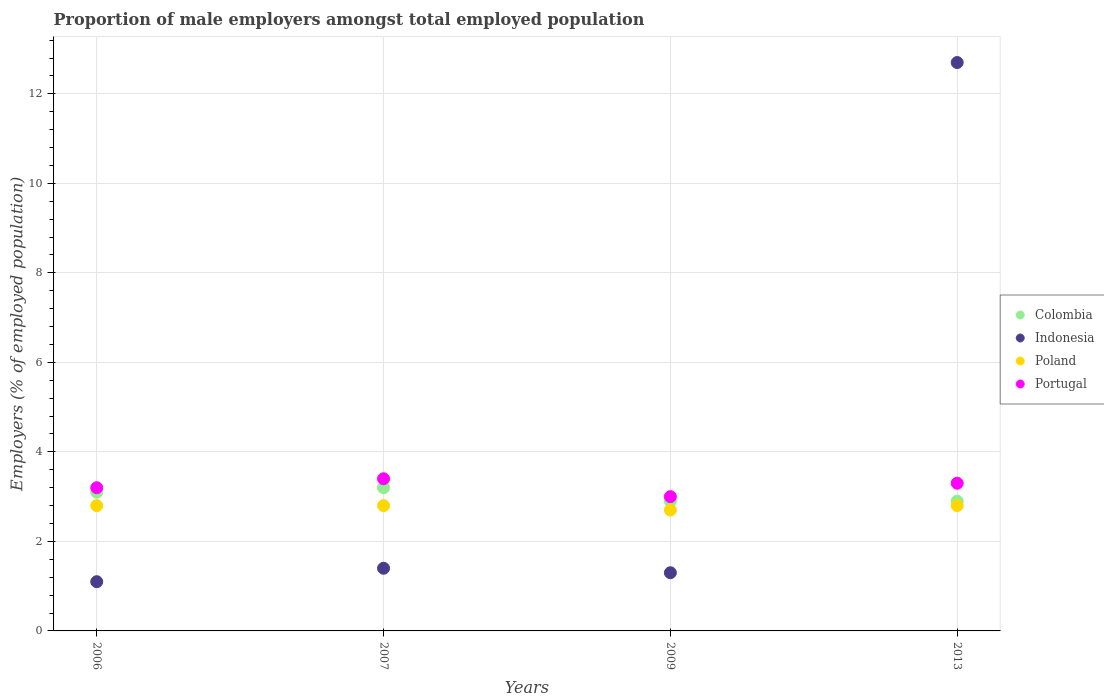What is the proportion of male employers in Indonesia in 2009?
Your response must be concise. 1.3. Across all years, what is the maximum proportion of male employers in Portugal?
Your answer should be very brief. 3.4. Across all years, what is the minimum proportion of male employers in Indonesia?
Make the answer very short. 1.1. What is the total proportion of male employers in Colombia in the graph?
Offer a very short reply. 12.1. What is the difference between the proportion of male employers in Portugal in 2013 and the proportion of male employers in Indonesia in 2007?
Your answer should be very brief. 1.9. What is the average proportion of male employers in Portugal per year?
Your answer should be compact. 3.23. In the year 2009, what is the difference between the proportion of male employers in Colombia and proportion of male employers in Portugal?
Provide a succinct answer. -0.1. In how many years, is the proportion of male employers in Indonesia greater than 12 %?
Provide a short and direct response. 1. Is the difference between the proportion of male employers in Colombia in 2006 and 2009 greater than the difference between the proportion of male employers in Portugal in 2006 and 2009?
Provide a short and direct response. No. What is the difference between the highest and the lowest proportion of male employers in Colombia?
Offer a very short reply. 0.3. In how many years, is the proportion of male employers in Colombia greater than the average proportion of male employers in Colombia taken over all years?
Give a very brief answer. 2. Is the sum of the proportion of male employers in Colombia in 2006 and 2013 greater than the maximum proportion of male employers in Poland across all years?
Offer a very short reply. Yes. Is it the case that in every year, the sum of the proportion of male employers in Portugal and proportion of male employers in Indonesia  is greater than the sum of proportion of male employers in Colombia and proportion of male employers in Poland?
Ensure brevity in your answer.  No. Does the proportion of male employers in Portugal monotonically increase over the years?
Offer a very short reply. No. Is the proportion of male employers in Indonesia strictly greater than the proportion of male employers in Poland over the years?
Your answer should be compact. No. Are the values on the major ticks of Y-axis written in scientific E-notation?
Give a very brief answer. No. Does the graph contain any zero values?
Give a very brief answer. No. What is the title of the graph?
Offer a very short reply. Proportion of male employers amongst total employed population. What is the label or title of the X-axis?
Offer a very short reply. Years. What is the label or title of the Y-axis?
Ensure brevity in your answer.  Employers (% of employed population). What is the Employers (% of employed population) in Colombia in 2006?
Your answer should be very brief. 3.1. What is the Employers (% of employed population) of Indonesia in 2006?
Keep it short and to the point. 1.1. What is the Employers (% of employed population) of Poland in 2006?
Provide a succinct answer. 2.8. What is the Employers (% of employed population) in Portugal in 2006?
Ensure brevity in your answer.  3.2. What is the Employers (% of employed population) of Colombia in 2007?
Give a very brief answer. 3.2. What is the Employers (% of employed population) of Indonesia in 2007?
Make the answer very short. 1.4. What is the Employers (% of employed population) in Poland in 2007?
Give a very brief answer. 2.8. What is the Employers (% of employed population) in Portugal in 2007?
Offer a very short reply. 3.4. What is the Employers (% of employed population) in Colombia in 2009?
Your answer should be compact. 2.9. What is the Employers (% of employed population) in Indonesia in 2009?
Ensure brevity in your answer.  1.3. What is the Employers (% of employed population) in Poland in 2009?
Provide a short and direct response. 2.7. What is the Employers (% of employed population) in Portugal in 2009?
Make the answer very short. 3. What is the Employers (% of employed population) of Colombia in 2013?
Offer a terse response. 2.9. What is the Employers (% of employed population) of Indonesia in 2013?
Your answer should be compact. 12.7. What is the Employers (% of employed population) in Poland in 2013?
Provide a succinct answer. 2.8. What is the Employers (% of employed population) in Portugal in 2013?
Your response must be concise. 3.3. Across all years, what is the maximum Employers (% of employed population) in Colombia?
Keep it short and to the point. 3.2. Across all years, what is the maximum Employers (% of employed population) of Indonesia?
Provide a short and direct response. 12.7. Across all years, what is the maximum Employers (% of employed population) of Poland?
Provide a succinct answer. 2.8. Across all years, what is the maximum Employers (% of employed population) of Portugal?
Your answer should be compact. 3.4. Across all years, what is the minimum Employers (% of employed population) of Colombia?
Provide a short and direct response. 2.9. Across all years, what is the minimum Employers (% of employed population) in Indonesia?
Your answer should be very brief. 1.1. Across all years, what is the minimum Employers (% of employed population) in Poland?
Offer a very short reply. 2.7. Across all years, what is the minimum Employers (% of employed population) of Portugal?
Offer a terse response. 3. What is the total Employers (% of employed population) in Colombia in the graph?
Give a very brief answer. 12.1. What is the difference between the Employers (% of employed population) of Colombia in 2006 and that in 2009?
Keep it short and to the point. 0.2. What is the difference between the Employers (% of employed population) in Indonesia in 2006 and that in 2009?
Your answer should be very brief. -0.2. What is the difference between the Employers (% of employed population) of Portugal in 2006 and that in 2009?
Your response must be concise. 0.2. What is the difference between the Employers (% of employed population) in Colombia in 2007 and that in 2009?
Your response must be concise. 0.3. What is the difference between the Employers (% of employed population) of Poland in 2007 and that in 2009?
Ensure brevity in your answer.  0.1. What is the difference between the Employers (% of employed population) of Indonesia in 2007 and that in 2013?
Give a very brief answer. -11.3. What is the difference between the Employers (% of employed population) of Poland in 2007 and that in 2013?
Provide a succinct answer. 0. What is the difference between the Employers (% of employed population) in Indonesia in 2009 and that in 2013?
Your answer should be very brief. -11.4. What is the difference between the Employers (% of employed population) in Poland in 2009 and that in 2013?
Ensure brevity in your answer.  -0.1. What is the difference between the Employers (% of employed population) of Colombia in 2006 and the Employers (% of employed population) of Indonesia in 2007?
Give a very brief answer. 1.7. What is the difference between the Employers (% of employed population) of Colombia in 2006 and the Employers (% of employed population) of Poland in 2007?
Your response must be concise. 0.3. What is the difference between the Employers (% of employed population) in Indonesia in 2006 and the Employers (% of employed population) in Poland in 2007?
Offer a terse response. -1.7. What is the difference between the Employers (% of employed population) in Poland in 2006 and the Employers (% of employed population) in Portugal in 2007?
Your response must be concise. -0.6. What is the difference between the Employers (% of employed population) in Colombia in 2006 and the Employers (% of employed population) in Poland in 2009?
Your response must be concise. 0.4. What is the difference between the Employers (% of employed population) in Indonesia in 2006 and the Employers (% of employed population) in Poland in 2009?
Your answer should be compact. -1.6. What is the difference between the Employers (% of employed population) in Indonesia in 2006 and the Employers (% of employed population) in Portugal in 2009?
Offer a very short reply. -1.9. What is the difference between the Employers (% of employed population) of Colombia in 2006 and the Employers (% of employed population) of Indonesia in 2013?
Your answer should be compact. -9.6. What is the difference between the Employers (% of employed population) of Colombia in 2006 and the Employers (% of employed population) of Poland in 2013?
Your answer should be compact. 0.3. What is the difference between the Employers (% of employed population) of Colombia in 2007 and the Employers (% of employed population) of Portugal in 2009?
Your response must be concise. 0.2. What is the difference between the Employers (% of employed population) of Poland in 2007 and the Employers (% of employed population) of Portugal in 2009?
Give a very brief answer. -0.2. What is the difference between the Employers (% of employed population) in Colombia in 2007 and the Employers (% of employed population) in Indonesia in 2013?
Your answer should be compact. -9.5. What is the difference between the Employers (% of employed population) in Colombia in 2007 and the Employers (% of employed population) in Poland in 2013?
Your answer should be compact. 0.4. What is the difference between the Employers (% of employed population) in Colombia in 2009 and the Employers (% of employed population) in Indonesia in 2013?
Your answer should be very brief. -9.8. What is the difference between the Employers (% of employed population) in Colombia in 2009 and the Employers (% of employed population) in Portugal in 2013?
Keep it short and to the point. -0.4. What is the difference between the Employers (% of employed population) in Poland in 2009 and the Employers (% of employed population) in Portugal in 2013?
Ensure brevity in your answer.  -0.6. What is the average Employers (% of employed population) in Colombia per year?
Give a very brief answer. 3.02. What is the average Employers (% of employed population) of Indonesia per year?
Keep it short and to the point. 4.12. What is the average Employers (% of employed population) in Poland per year?
Offer a very short reply. 2.77. What is the average Employers (% of employed population) of Portugal per year?
Provide a succinct answer. 3.23. In the year 2006, what is the difference between the Employers (% of employed population) of Colombia and Employers (% of employed population) of Indonesia?
Ensure brevity in your answer.  2. In the year 2006, what is the difference between the Employers (% of employed population) in Colombia and Employers (% of employed population) in Portugal?
Make the answer very short. -0.1. In the year 2006, what is the difference between the Employers (% of employed population) of Indonesia and Employers (% of employed population) of Poland?
Your answer should be very brief. -1.7. In the year 2006, what is the difference between the Employers (% of employed population) in Indonesia and Employers (% of employed population) in Portugal?
Keep it short and to the point. -2.1. In the year 2007, what is the difference between the Employers (% of employed population) in Colombia and Employers (% of employed population) in Indonesia?
Your answer should be compact. 1.8. In the year 2007, what is the difference between the Employers (% of employed population) in Colombia and Employers (% of employed population) in Poland?
Provide a short and direct response. 0.4. In the year 2007, what is the difference between the Employers (% of employed population) in Colombia and Employers (% of employed population) in Portugal?
Make the answer very short. -0.2. In the year 2007, what is the difference between the Employers (% of employed population) in Indonesia and Employers (% of employed population) in Portugal?
Offer a very short reply. -2. In the year 2009, what is the difference between the Employers (% of employed population) of Colombia and Employers (% of employed population) of Indonesia?
Your answer should be compact. 1.6. In the year 2009, what is the difference between the Employers (% of employed population) in Colombia and Employers (% of employed population) in Poland?
Offer a very short reply. 0.2. In the year 2009, what is the difference between the Employers (% of employed population) in Indonesia and Employers (% of employed population) in Poland?
Make the answer very short. -1.4. In the year 2009, what is the difference between the Employers (% of employed population) in Indonesia and Employers (% of employed population) in Portugal?
Offer a terse response. -1.7. In the year 2009, what is the difference between the Employers (% of employed population) in Poland and Employers (% of employed population) in Portugal?
Provide a short and direct response. -0.3. In the year 2013, what is the difference between the Employers (% of employed population) in Colombia and Employers (% of employed population) in Indonesia?
Ensure brevity in your answer.  -9.8. In the year 2013, what is the difference between the Employers (% of employed population) of Colombia and Employers (% of employed population) of Portugal?
Give a very brief answer. -0.4. In the year 2013, what is the difference between the Employers (% of employed population) of Indonesia and Employers (% of employed population) of Portugal?
Provide a succinct answer. 9.4. What is the ratio of the Employers (% of employed population) of Colombia in 2006 to that in 2007?
Offer a terse response. 0.97. What is the ratio of the Employers (% of employed population) of Indonesia in 2006 to that in 2007?
Offer a terse response. 0.79. What is the ratio of the Employers (% of employed population) in Poland in 2006 to that in 2007?
Offer a very short reply. 1. What is the ratio of the Employers (% of employed population) of Colombia in 2006 to that in 2009?
Offer a terse response. 1.07. What is the ratio of the Employers (% of employed population) of Indonesia in 2006 to that in 2009?
Give a very brief answer. 0.85. What is the ratio of the Employers (% of employed population) of Poland in 2006 to that in 2009?
Offer a terse response. 1.04. What is the ratio of the Employers (% of employed population) in Portugal in 2006 to that in 2009?
Your answer should be very brief. 1.07. What is the ratio of the Employers (% of employed population) of Colombia in 2006 to that in 2013?
Provide a short and direct response. 1.07. What is the ratio of the Employers (% of employed population) of Indonesia in 2006 to that in 2013?
Your answer should be compact. 0.09. What is the ratio of the Employers (% of employed population) in Portugal in 2006 to that in 2013?
Provide a succinct answer. 0.97. What is the ratio of the Employers (% of employed population) in Colombia in 2007 to that in 2009?
Offer a terse response. 1.1. What is the ratio of the Employers (% of employed population) of Indonesia in 2007 to that in 2009?
Offer a very short reply. 1.08. What is the ratio of the Employers (% of employed population) of Poland in 2007 to that in 2009?
Make the answer very short. 1.04. What is the ratio of the Employers (% of employed population) of Portugal in 2007 to that in 2009?
Give a very brief answer. 1.13. What is the ratio of the Employers (% of employed population) in Colombia in 2007 to that in 2013?
Offer a terse response. 1.1. What is the ratio of the Employers (% of employed population) in Indonesia in 2007 to that in 2013?
Your response must be concise. 0.11. What is the ratio of the Employers (% of employed population) in Poland in 2007 to that in 2013?
Your response must be concise. 1. What is the ratio of the Employers (% of employed population) in Portugal in 2007 to that in 2013?
Make the answer very short. 1.03. What is the ratio of the Employers (% of employed population) in Indonesia in 2009 to that in 2013?
Make the answer very short. 0.1. What is the ratio of the Employers (% of employed population) of Portugal in 2009 to that in 2013?
Make the answer very short. 0.91. What is the difference between the highest and the second highest Employers (% of employed population) in Indonesia?
Ensure brevity in your answer.  11.3. What is the difference between the highest and the lowest Employers (% of employed population) of Colombia?
Keep it short and to the point. 0.3. What is the difference between the highest and the lowest Employers (% of employed population) in Indonesia?
Offer a terse response. 11.6. What is the difference between the highest and the lowest Employers (% of employed population) of Portugal?
Provide a short and direct response. 0.4. 